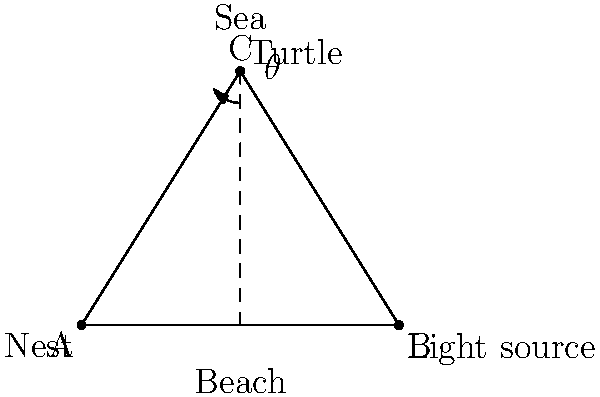A sea turtle emerges from its nest at point A and needs to reach the sea at the top of the diagram. However, an artificial light source at point B is interfering with its path. If the turtle is currently at point C, what is the angle $\theta$ between the turtle's ideal path to the sea and its path towards the light source? Give your answer to the nearest degree. To solve this problem, we'll follow these steps:

1) First, we need to identify the ideal path and the path towards the light source:
   - The ideal path is from C straight to the sea (vertically upwards)
   - The path towards the light source is from C to B

2) We can treat this as a right-angled triangle problem, where:
   - The vertical line from C to the beach is the height
   - The horizontal distance from A to B is the base
   - The line from C to B is the hypotenuse

3) We can calculate the angle using the arctangent function:

   $$\theta = 90° - \arctan(\frac{\text{height}}{\text{base}})$$

4) From the diagram:
   - The base (distance AB) is 10 units
   - The height (vertical distance from C to the beach) is 8 units

5) Plugging these values into our formula:

   $$\theta = 90° - \arctan(\frac{8}{10})$$

6) Calculate:
   $$\theta = 90° - \arctan(0.8)$$
   $$\theta = 90° - 38.66°$$
   $$\theta = 51.34°$$

7) Rounding to the nearest degree:
   $$\theta \approx 51°$$
Answer: 51° 